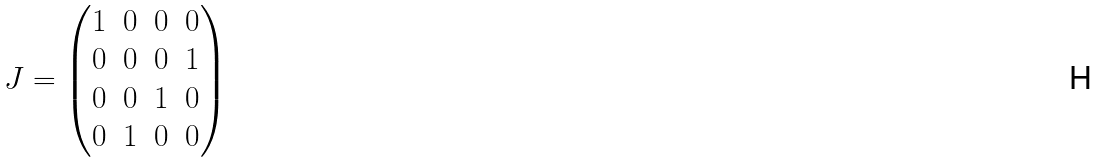Convert formula to latex. <formula><loc_0><loc_0><loc_500><loc_500>J = \begin{pmatrix} 1 & 0 & 0 & 0 \\ 0 & 0 & 0 & 1 \\ 0 & 0 & 1 & 0 \\ 0 & 1 & 0 & 0 \end{pmatrix}</formula> 